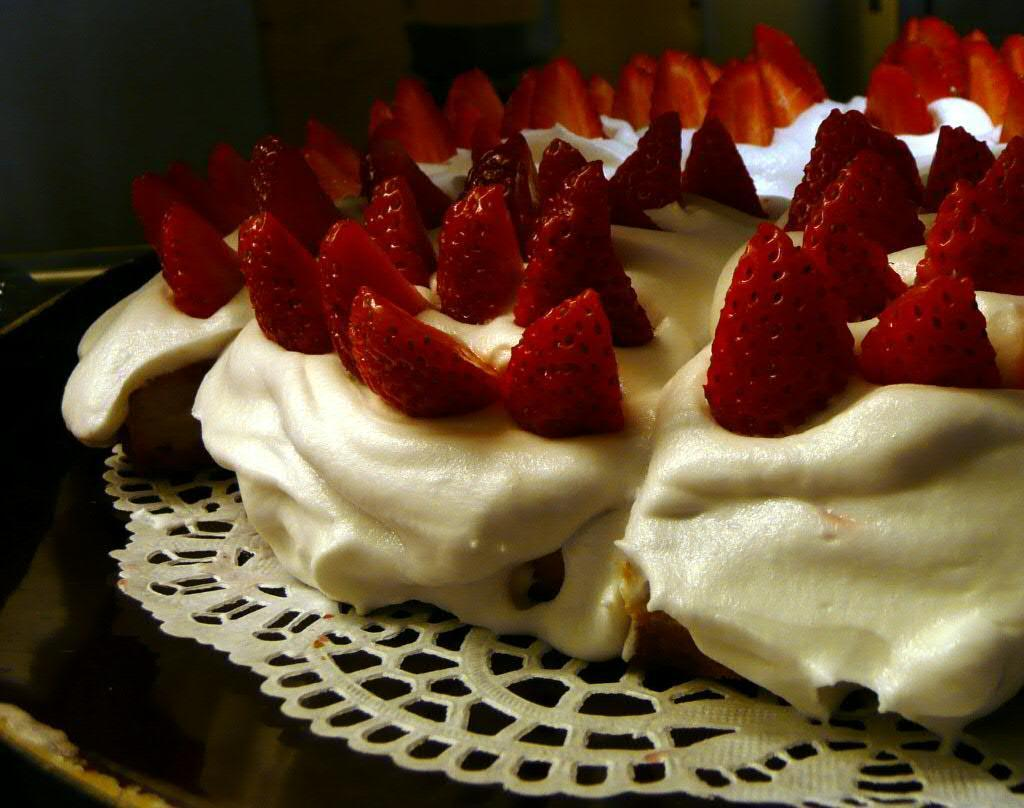What type of fruit is present in the image? There are strawberries in the image. How are the strawberries arranged in the image? The strawberries are on top of cream. Where is the cream placed in the image? The cream is placed on a table. What type of tools does the carpenter use to create the gold sister in the image? There is no carpenter, gold, or sister present in the image. 